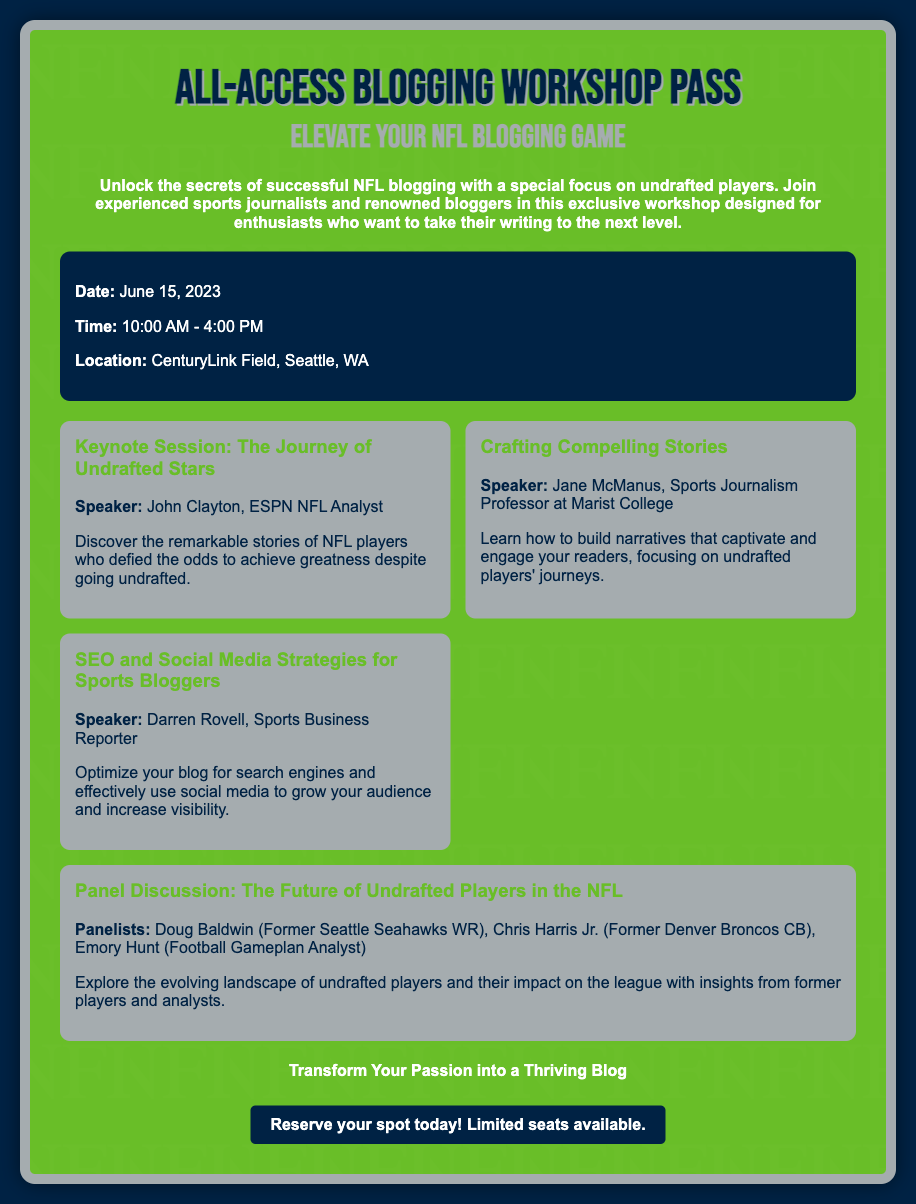what is the title of the workshop? The title of the workshop is prominently displayed at the top of the document.
Answer: All-Access Blogging Workshop Pass what is the date of the workshop? The date is mentioned in the event details section of the document.
Answer: June 15, 2023 who is the keynote speaker for the session on undrafted stars? The speaker for the keynote session is specified in the highlights section.
Answer: John Clayton what are the workshop hours? The hours are listed in the event details section.
Answer: 10:00 AM - 4:00 PM where is the workshop location? The location of the workshop is included in the event details section.
Answer: CenturyLink Field, Seattle, WA what is one of the workshop highlights focused on? The highlights section mentions various topics, one of which pertains to engaging readers.
Answer: Crafting Compelling Stories how many panelists are mentioned for the panel discussion? The number of panelists is detailed in the panel discussion highlight.
Answer: Three what can attendees transform their passion into? The footer of the document states the purpose of the workshop for attendees.
Answer: A Thriving Blog what is the main theme of the workshop? The overall theme of the workshop is described in the introductory paragraph.
Answer: NFL Blogging about Undrafted Players 